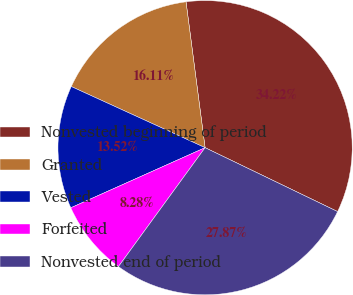<chart> <loc_0><loc_0><loc_500><loc_500><pie_chart><fcel>Nonvested beginning of period<fcel>Granted<fcel>Vested<fcel>Forfeited<fcel>Nonvested end of period<nl><fcel>34.22%<fcel>16.11%<fcel>13.52%<fcel>8.28%<fcel>27.87%<nl></chart> 